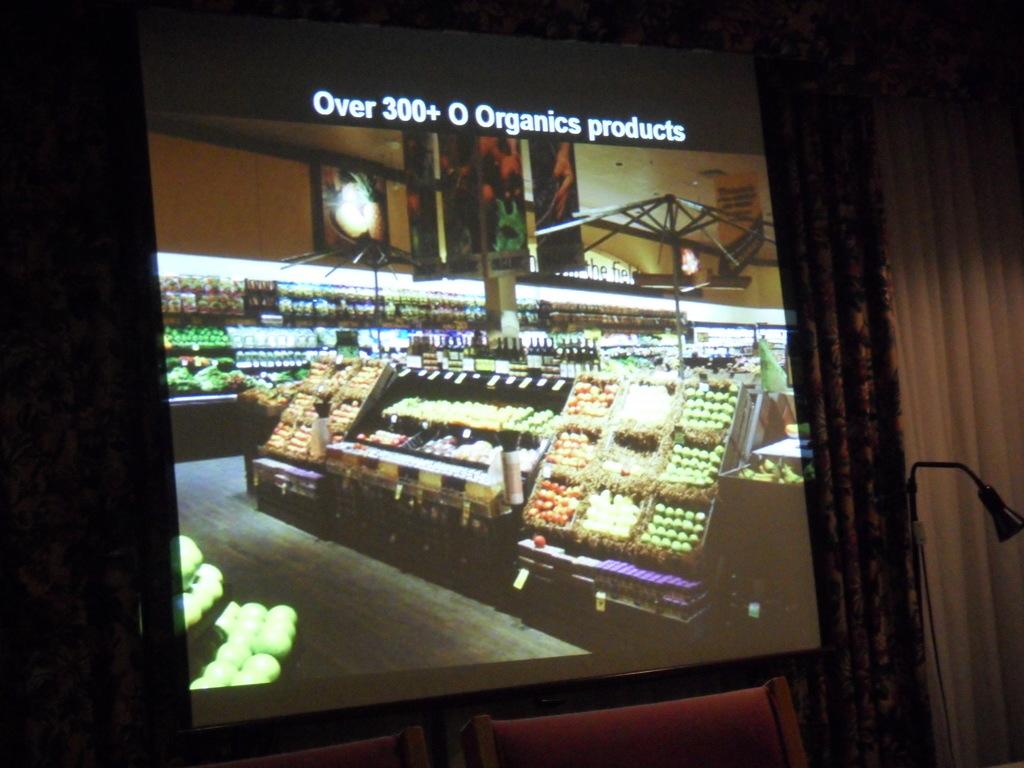How many organic products do they carry?
Offer a terse response. 300+. What kind of products do they carry?
Provide a short and direct response. Organic. 